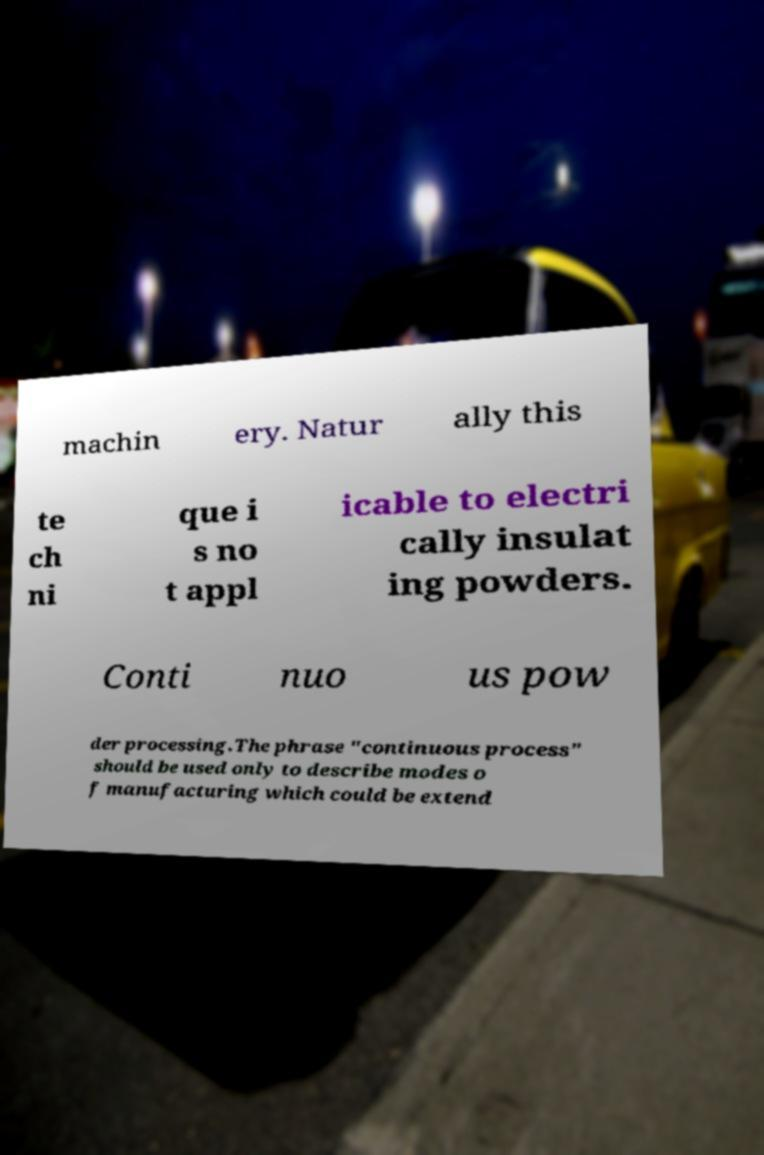Can you read and provide the text displayed in the image?This photo seems to have some interesting text. Can you extract and type it out for me? machin ery. Natur ally this te ch ni que i s no t appl icable to electri cally insulat ing powders. Conti nuo us pow der processing.The phrase "continuous process" should be used only to describe modes o f manufacturing which could be extend 